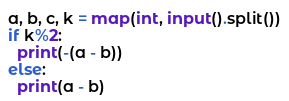Convert code to text. <code><loc_0><loc_0><loc_500><loc_500><_Python_>a, b, c, k = map(int, input().split())
if k%2:
  print(-(a - b))
else:
  print(a - b)</code> 